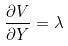Convert formula to latex. <formula><loc_0><loc_0><loc_500><loc_500>\frac { \partial V } { \partial Y } = \lambda</formula> 